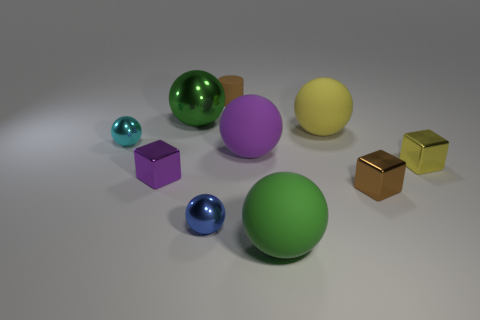What is the color of the tiny ball that is in front of the yellow thing in front of the cyan ball?
Make the answer very short. Blue. There is a big sphere that is the same color as the big shiny thing; what is its material?
Your answer should be very brief. Rubber. The tiny thing behind the tiny cyan metal object is what color?
Your answer should be very brief. Brown. Is the size of the green ball behind the brown block the same as the big purple thing?
Make the answer very short. Yes. The cube that is the same color as the rubber cylinder is what size?
Keep it short and to the point. Small. Do the matte object that is in front of the blue sphere and the big sphere left of the tiny blue shiny ball have the same color?
Ensure brevity in your answer.  Yes. Is there a thing of the same color as the small cylinder?
Your answer should be compact. Yes. What number of other things are there of the same shape as the purple rubber object?
Give a very brief answer. 5. The tiny brown thing behind the tiny brown cube has what shape?
Make the answer very short. Cylinder. Do the tiny yellow metallic thing and the purple object left of the small blue ball have the same shape?
Keep it short and to the point. Yes. 